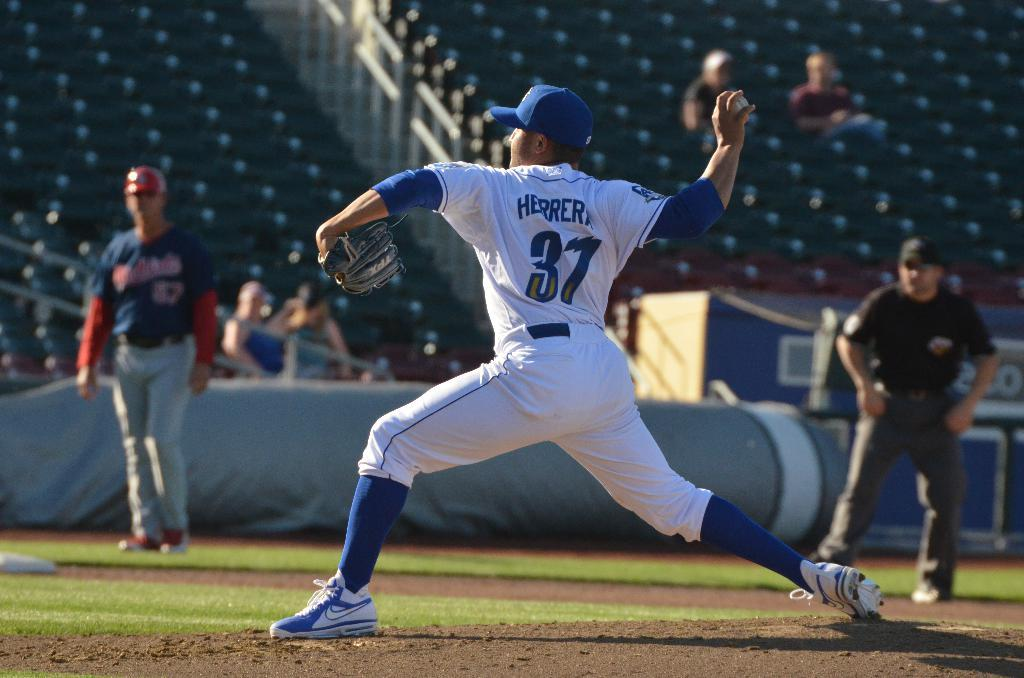<image>
Describe the image concisely. A baseball player is pitching the ball and his jersey says Herrerk 37. 